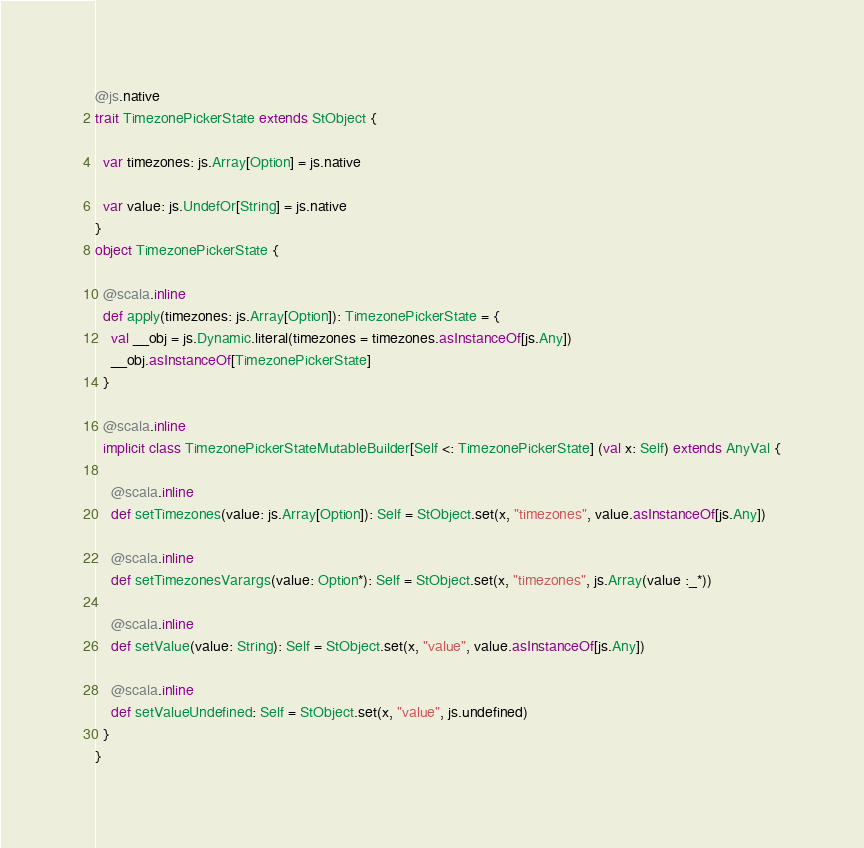<code> <loc_0><loc_0><loc_500><loc_500><_Scala_>
@js.native
trait TimezonePickerState extends StObject {
  
  var timezones: js.Array[Option] = js.native
  
  var value: js.UndefOr[String] = js.native
}
object TimezonePickerState {
  
  @scala.inline
  def apply(timezones: js.Array[Option]): TimezonePickerState = {
    val __obj = js.Dynamic.literal(timezones = timezones.asInstanceOf[js.Any])
    __obj.asInstanceOf[TimezonePickerState]
  }
  
  @scala.inline
  implicit class TimezonePickerStateMutableBuilder[Self <: TimezonePickerState] (val x: Self) extends AnyVal {
    
    @scala.inline
    def setTimezones(value: js.Array[Option]): Self = StObject.set(x, "timezones", value.asInstanceOf[js.Any])
    
    @scala.inline
    def setTimezonesVarargs(value: Option*): Self = StObject.set(x, "timezones", js.Array(value :_*))
    
    @scala.inline
    def setValue(value: String): Self = StObject.set(x, "value", value.asInstanceOf[js.Any])
    
    @scala.inline
    def setValueUndefined: Self = StObject.set(x, "value", js.undefined)
  }
}
</code> 